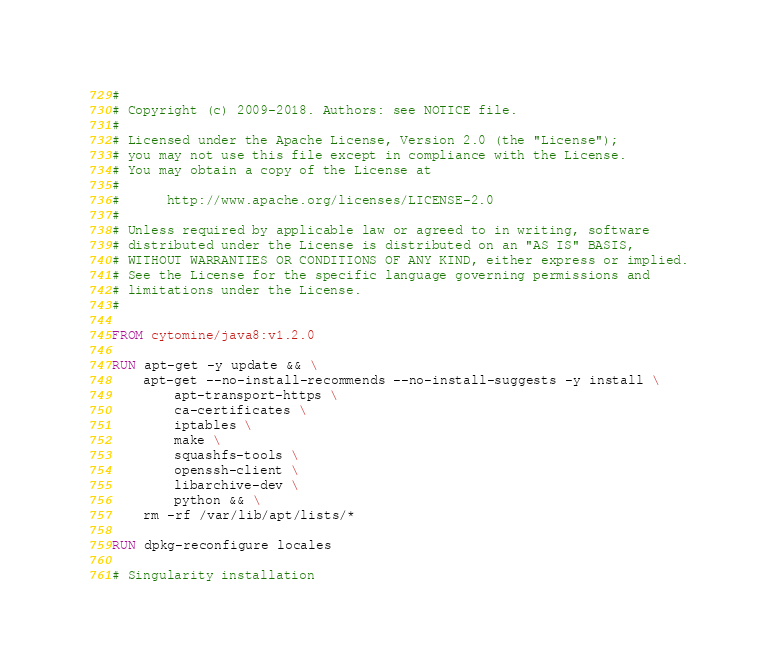<code> <loc_0><loc_0><loc_500><loc_500><_Dockerfile_>#
# Copyright (c) 2009-2018. Authors: see NOTICE file.
#
# Licensed under the Apache License, Version 2.0 (the "License");
# you may not use this file except in compliance with the License.
# You may obtain a copy of the License at
#
#      http://www.apache.org/licenses/LICENSE-2.0
#
# Unless required by applicable law or agreed to in writing, software
# distributed under the License is distributed on an "AS IS" BASIS,
# WITHOUT WARRANTIES OR CONDITIONS OF ANY KIND, either express or implied.
# See the License for the specific language governing permissions and
# limitations under the License.
#

FROM cytomine/java8:v1.2.0

RUN apt-get -y update && \
    apt-get --no-install-recommends --no-install-suggests -y install \
        apt-transport-https \
        ca-certificates \
        iptables \
        make \
        squashfs-tools \
        openssh-client \
        libarchive-dev \
        python && \
    rm -rf /var/lib/apt/lists/*

RUN dpkg-reconfigure locales

# Singularity installation</code> 